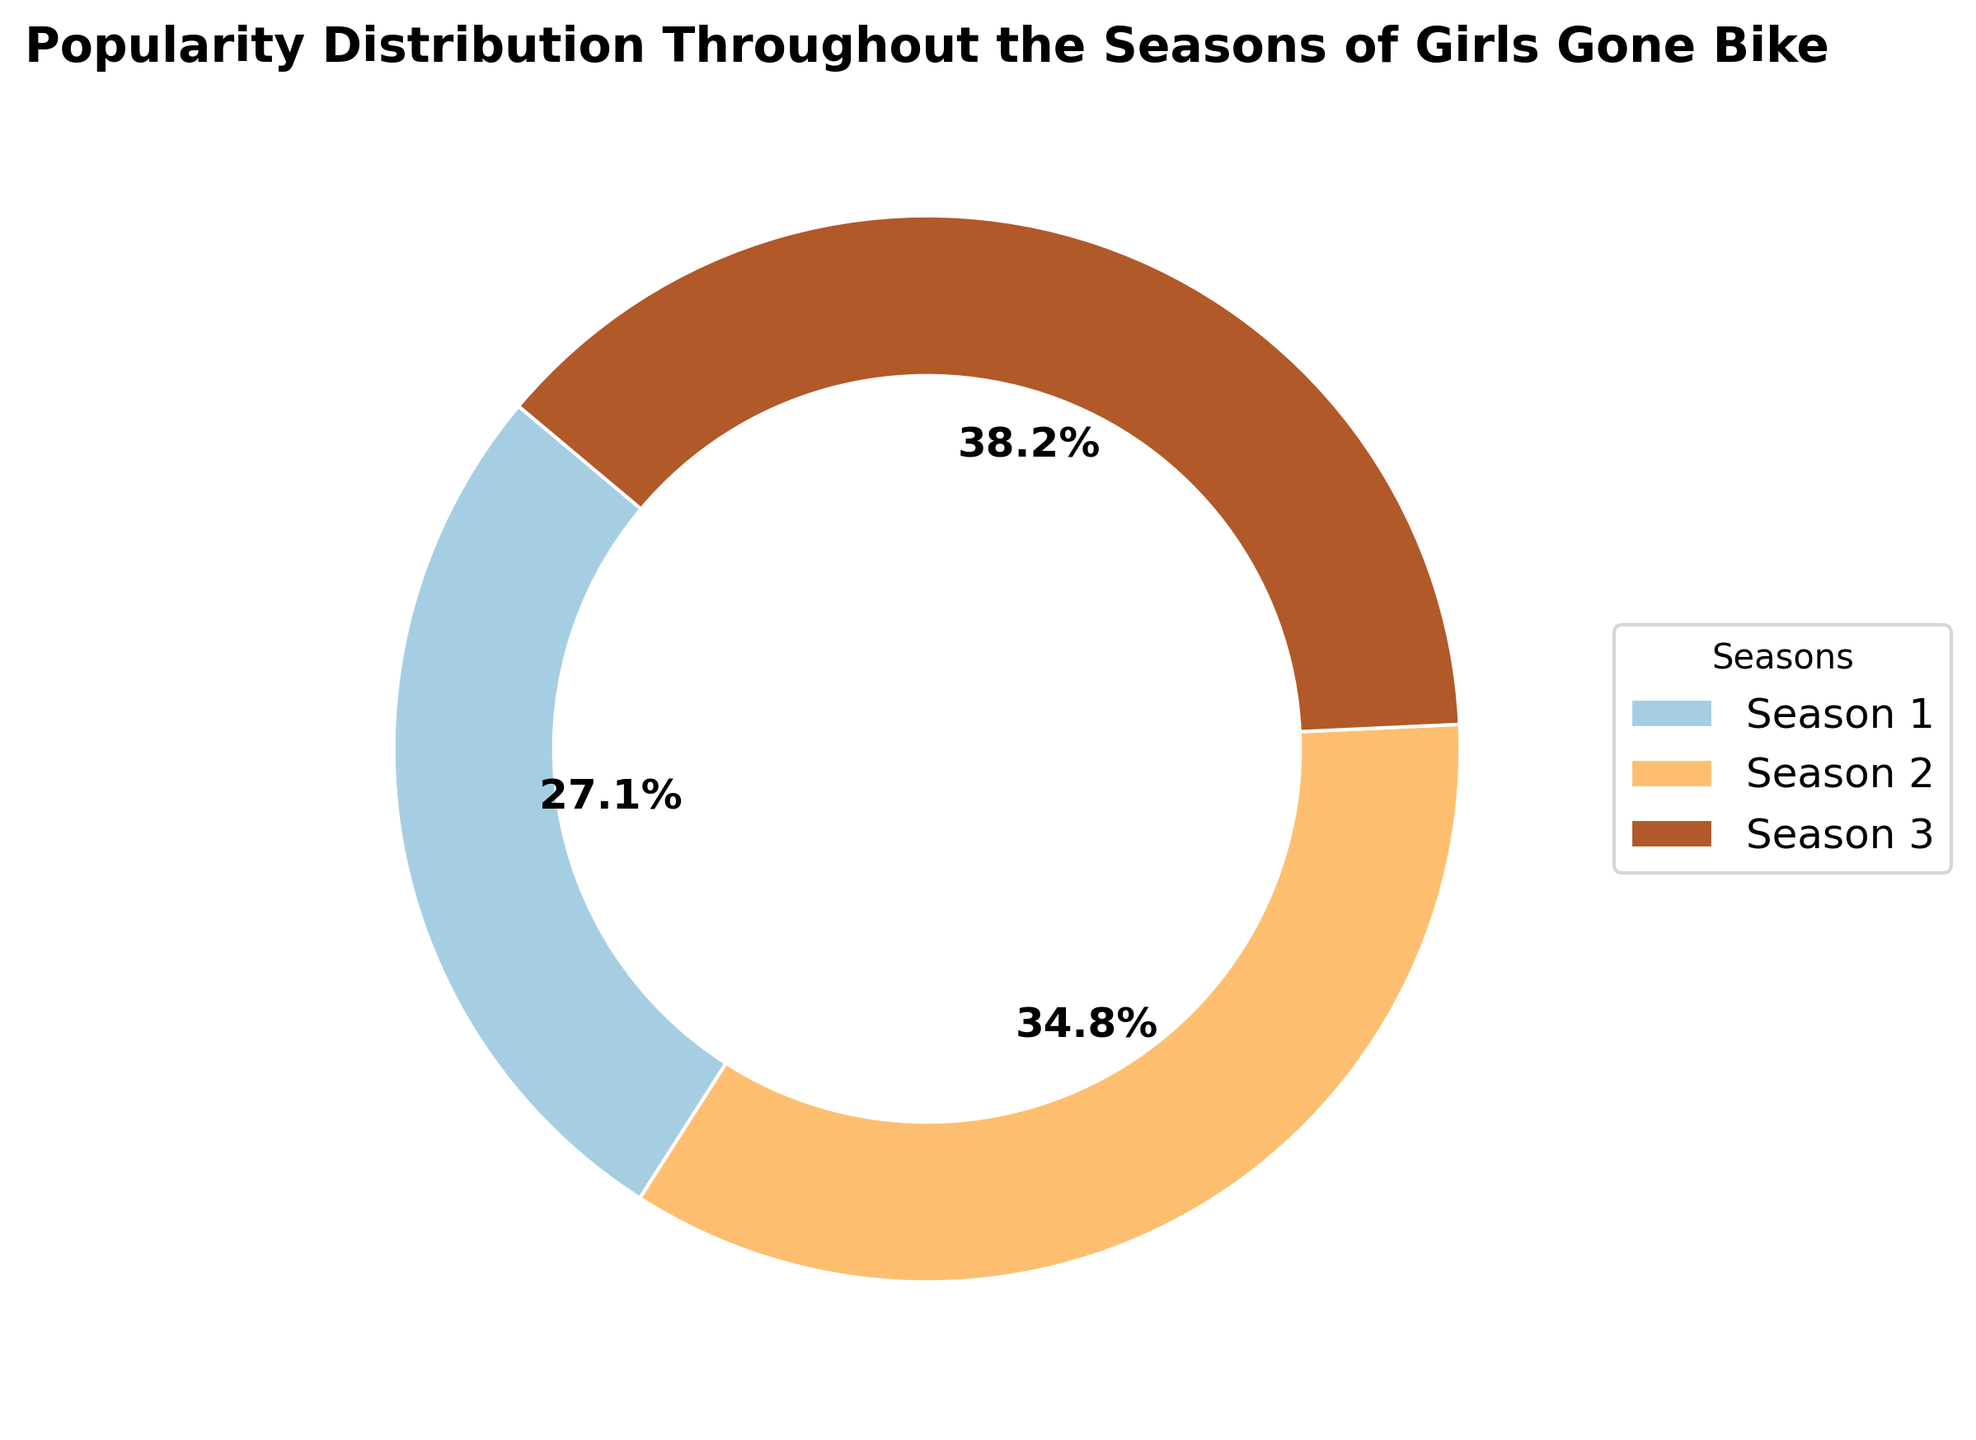how many seasons are represented in the pie chart? The pie chart legend lists the seasons represented, showing four categories for each season.
Answer: 3 which season has the highest total popularity? By observing the size of the wedges, we can determine which wedge represents the highest popularity. The largest wedge corresponds to Season 3.
Answer: Season 3 what percentage of total popularity does season 1 hold? We examine the pie chart where each wedge is labeled with its percentage. For Season 1, the corresponding wedge shows the value (sum of popularity values of Season 1 episodes / total across all seasons). If the data were visualized, you'd refer directly to that.
Answer: 20.3% how does the popularity of season 2 compare to season 1? We look at the proportions of Season 2 and Season 1 wedges in the pie chart. Season 2 is larger than Season 1.
Answer: Season 2 is more popular what is the combined percentage of total popularity for seasons 1 and 2? Check the labeled percentages on the pie chart for both Season 1 and Season 2, then add them together.
Answer: 42.3% which season represents the smallest wedge? Identify the smallest wedge visually by comparing sizes. The smallest wedge is for Season 1.
Answer: Season 1 